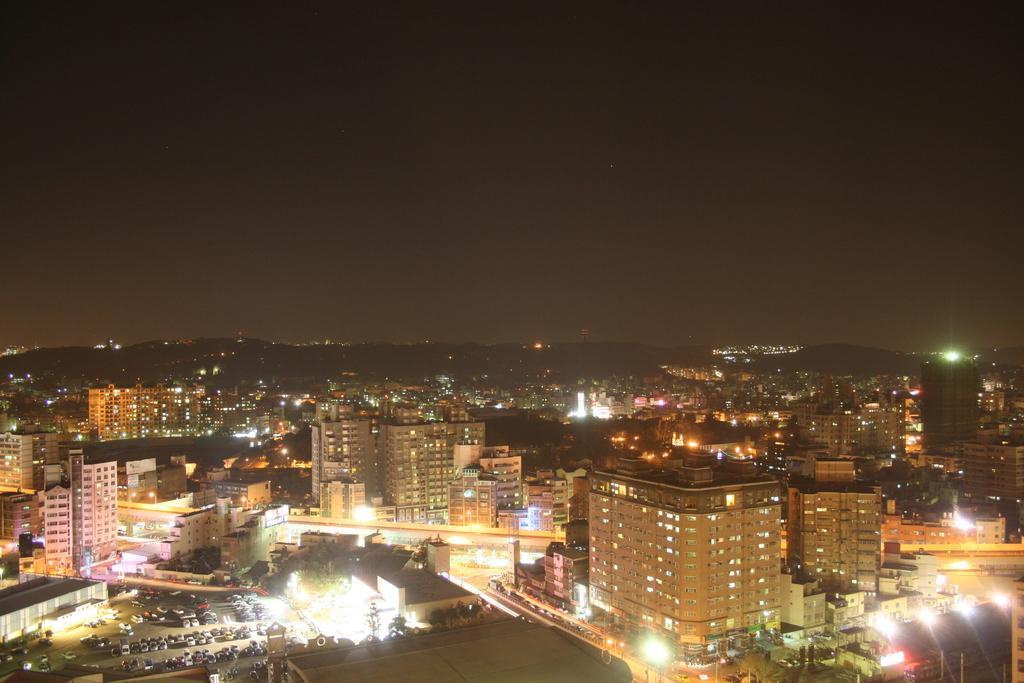Could you give a brief overview of what you see in this image? This picture is clicked outside the city. There are many buildings in this picture. At the bottom of the picture, there are many cars parked on the road. There are many street lights on the road. There are trees and buildings in the background. At the top of the picture, we see the sky. This picture is clicked in the dark. 